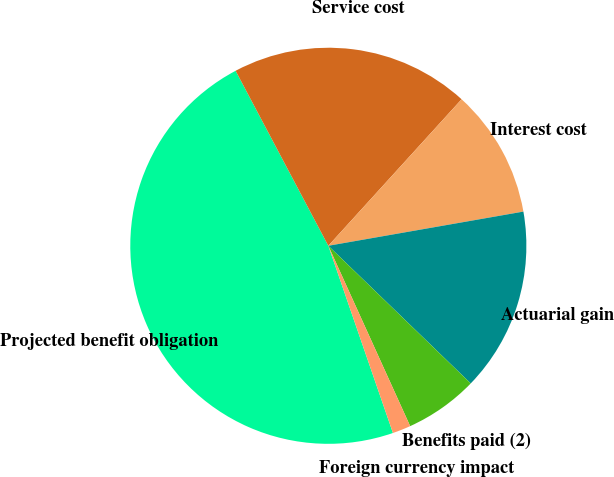Convert chart to OTSL. <chart><loc_0><loc_0><loc_500><loc_500><pie_chart><fcel>Projected benefit obligation<fcel>Service cost<fcel>Interest cost<fcel>Actuarial gain<fcel>Benefits paid (2)<fcel>Foreign currency impact<nl><fcel>47.53%<fcel>19.5%<fcel>10.49%<fcel>14.99%<fcel>5.99%<fcel>1.49%<nl></chart> 